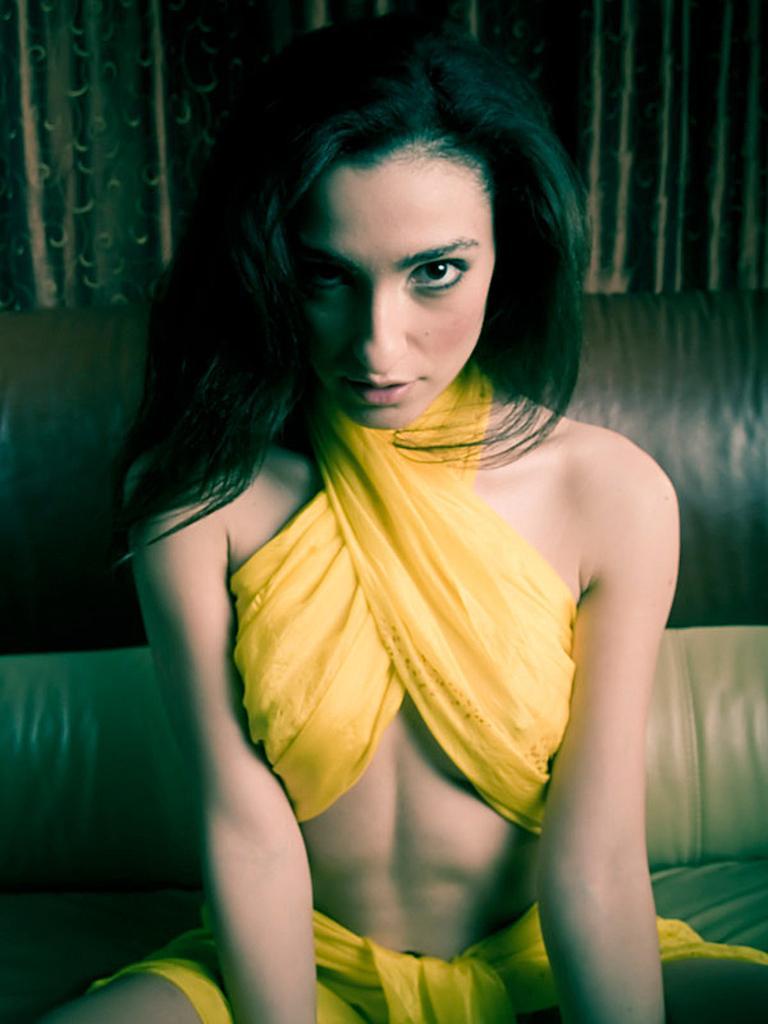Could you give a brief overview of what you see in this image? In this picture I can see a woman sitting on the couch, and in the background there are curtains. 